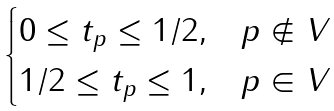Convert formula to latex. <formula><loc_0><loc_0><loc_500><loc_500>\begin{cases} 0 \leq t _ { p } \leq 1 / 2 , & p \notin V \\ 1 / 2 \leq t _ { p } \leq 1 , & p \in V \end{cases}</formula> 